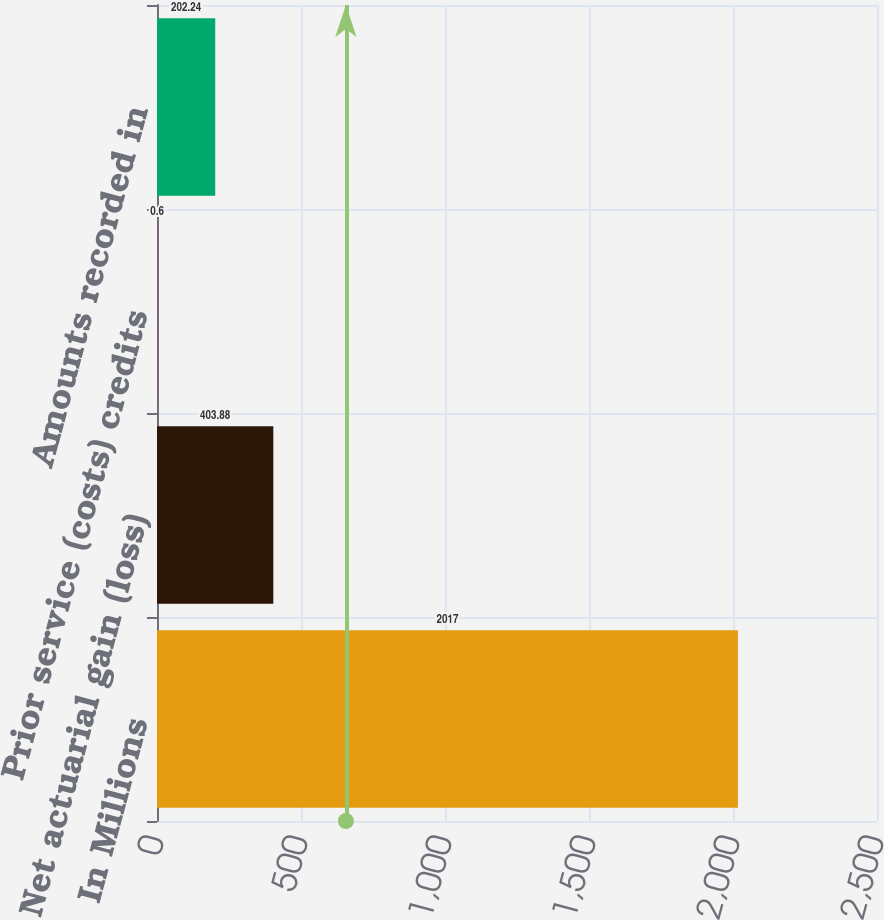<chart> <loc_0><loc_0><loc_500><loc_500><bar_chart><fcel>In Millions<fcel>Net actuarial gain (loss)<fcel>Prior service (costs) credits<fcel>Amounts recorded in<nl><fcel>2017<fcel>403.88<fcel>0.6<fcel>202.24<nl></chart> 